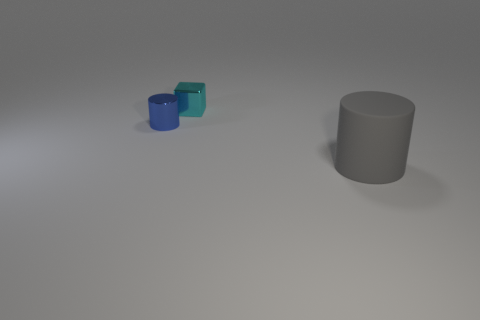Subtract all gray cylinders. How many cylinders are left? 1 Subtract 2 cylinders. How many cylinders are left? 0 Subtract all cyan cylinders. Subtract all yellow blocks. How many cylinders are left? 2 Subtract all red cubes. How many blue cylinders are left? 1 Add 1 tiny blue objects. How many tiny blue objects are left? 2 Add 1 big gray matte cubes. How many big gray matte cubes exist? 1 Add 1 tiny yellow objects. How many objects exist? 4 Subtract 1 blue cylinders. How many objects are left? 2 Subtract all blocks. How many objects are left? 2 Subtract all cyan metallic things. Subtract all large cylinders. How many objects are left? 1 